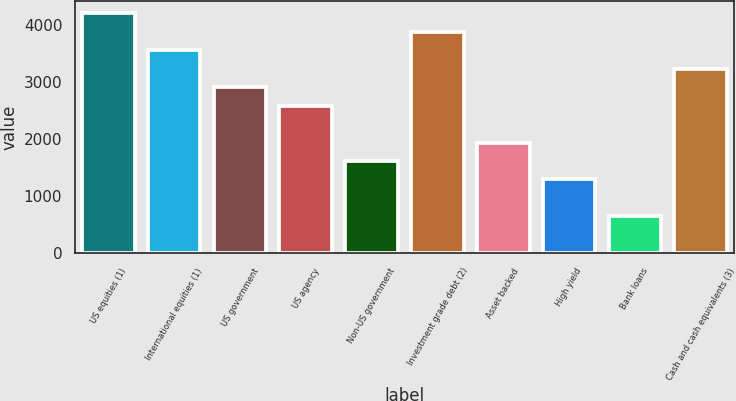Convert chart to OTSL. <chart><loc_0><loc_0><loc_500><loc_500><bar_chart><fcel>US equities (1)<fcel>International equities (1)<fcel>US government<fcel>US agency<fcel>Non-US government<fcel>Investment grade debt (2)<fcel>Asset backed<fcel>High yield<fcel>Bank loans<fcel>Cash and cash equivalents (3)<nl><fcel>4210.36<fcel>3562.78<fcel>2915.2<fcel>2591.41<fcel>1620.04<fcel>3886.57<fcel>1943.83<fcel>1296.25<fcel>648.67<fcel>3238.99<nl></chart> 